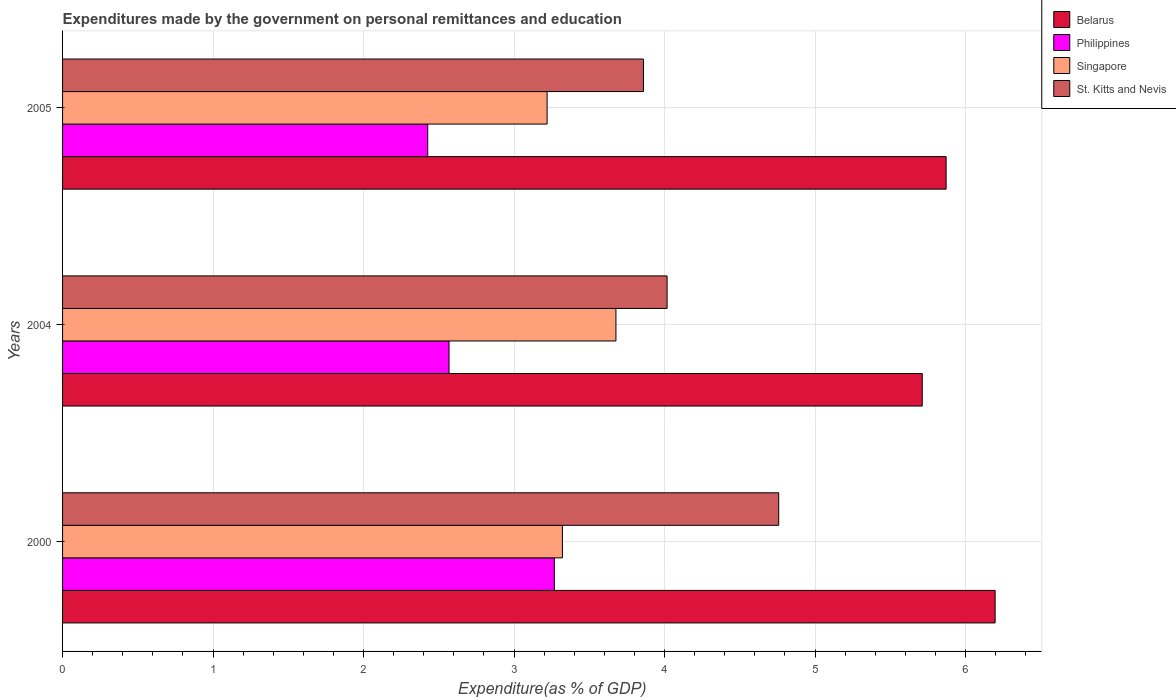How many different coloured bars are there?
Your answer should be compact. 4. Are the number of bars per tick equal to the number of legend labels?
Give a very brief answer. Yes. Are the number of bars on each tick of the Y-axis equal?
Provide a succinct answer. Yes. How many bars are there on the 1st tick from the top?
Ensure brevity in your answer.  4. How many bars are there on the 3rd tick from the bottom?
Make the answer very short. 4. What is the expenditures made by the government on personal remittances and education in St. Kitts and Nevis in 2004?
Provide a short and direct response. 4.02. Across all years, what is the maximum expenditures made by the government on personal remittances and education in Philippines?
Make the answer very short. 3.27. Across all years, what is the minimum expenditures made by the government on personal remittances and education in Philippines?
Your answer should be compact. 2.43. In which year was the expenditures made by the government on personal remittances and education in Belarus maximum?
Keep it short and to the point. 2000. In which year was the expenditures made by the government on personal remittances and education in St. Kitts and Nevis minimum?
Make the answer very short. 2005. What is the total expenditures made by the government on personal remittances and education in Belarus in the graph?
Offer a terse response. 17.78. What is the difference between the expenditures made by the government on personal remittances and education in Belarus in 2000 and that in 2005?
Offer a terse response. 0.33. What is the difference between the expenditures made by the government on personal remittances and education in Singapore in 2004 and the expenditures made by the government on personal remittances and education in St. Kitts and Nevis in 2000?
Offer a terse response. -1.08. What is the average expenditures made by the government on personal remittances and education in Singapore per year?
Offer a very short reply. 3.41. In the year 2000, what is the difference between the expenditures made by the government on personal remittances and education in Singapore and expenditures made by the government on personal remittances and education in St. Kitts and Nevis?
Ensure brevity in your answer.  -1.44. In how many years, is the expenditures made by the government on personal remittances and education in Singapore greater than 6 %?
Provide a short and direct response. 0. What is the ratio of the expenditures made by the government on personal remittances and education in Belarus in 2000 to that in 2005?
Your answer should be compact. 1.06. Is the expenditures made by the government on personal remittances and education in Belarus in 2000 less than that in 2005?
Your response must be concise. No. What is the difference between the highest and the second highest expenditures made by the government on personal remittances and education in Belarus?
Provide a succinct answer. 0.33. What is the difference between the highest and the lowest expenditures made by the government on personal remittances and education in Singapore?
Provide a short and direct response. 0.46. In how many years, is the expenditures made by the government on personal remittances and education in St. Kitts and Nevis greater than the average expenditures made by the government on personal remittances and education in St. Kitts and Nevis taken over all years?
Your response must be concise. 1. What does the 2nd bar from the top in 2000 represents?
Give a very brief answer. Singapore. What does the 3rd bar from the bottom in 2000 represents?
Provide a succinct answer. Singapore. Is it the case that in every year, the sum of the expenditures made by the government on personal remittances and education in Singapore and expenditures made by the government on personal remittances and education in Philippines is greater than the expenditures made by the government on personal remittances and education in Belarus?
Give a very brief answer. No. How many bars are there?
Your answer should be compact. 12. How many years are there in the graph?
Your answer should be compact. 3. Does the graph contain grids?
Provide a short and direct response. Yes. Where does the legend appear in the graph?
Keep it short and to the point. Top right. How are the legend labels stacked?
Your answer should be very brief. Vertical. What is the title of the graph?
Keep it short and to the point. Expenditures made by the government on personal remittances and education. What is the label or title of the X-axis?
Give a very brief answer. Expenditure(as % of GDP). What is the label or title of the Y-axis?
Provide a succinct answer. Years. What is the Expenditure(as % of GDP) in Belarus in 2000?
Keep it short and to the point. 6.2. What is the Expenditure(as % of GDP) in Philippines in 2000?
Provide a succinct answer. 3.27. What is the Expenditure(as % of GDP) in Singapore in 2000?
Give a very brief answer. 3.32. What is the Expenditure(as % of GDP) in St. Kitts and Nevis in 2000?
Ensure brevity in your answer.  4.76. What is the Expenditure(as % of GDP) in Belarus in 2004?
Offer a terse response. 5.71. What is the Expenditure(as % of GDP) in Philippines in 2004?
Give a very brief answer. 2.57. What is the Expenditure(as % of GDP) in Singapore in 2004?
Provide a succinct answer. 3.68. What is the Expenditure(as % of GDP) in St. Kitts and Nevis in 2004?
Give a very brief answer. 4.02. What is the Expenditure(as % of GDP) in Belarus in 2005?
Ensure brevity in your answer.  5.87. What is the Expenditure(as % of GDP) in Philippines in 2005?
Your response must be concise. 2.43. What is the Expenditure(as % of GDP) in Singapore in 2005?
Provide a succinct answer. 3.22. What is the Expenditure(as % of GDP) in St. Kitts and Nevis in 2005?
Make the answer very short. 3.86. Across all years, what is the maximum Expenditure(as % of GDP) of Belarus?
Keep it short and to the point. 6.2. Across all years, what is the maximum Expenditure(as % of GDP) of Philippines?
Offer a very short reply. 3.27. Across all years, what is the maximum Expenditure(as % of GDP) in Singapore?
Keep it short and to the point. 3.68. Across all years, what is the maximum Expenditure(as % of GDP) in St. Kitts and Nevis?
Offer a terse response. 4.76. Across all years, what is the minimum Expenditure(as % of GDP) in Belarus?
Provide a succinct answer. 5.71. Across all years, what is the minimum Expenditure(as % of GDP) in Philippines?
Ensure brevity in your answer.  2.43. Across all years, what is the minimum Expenditure(as % of GDP) of Singapore?
Your answer should be compact. 3.22. Across all years, what is the minimum Expenditure(as % of GDP) in St. Kitts and Nevis?
Make the answer very short. 3.86. What is the total Expenditure(as % of GDP) of Belarus in the graph?
Offer a terse response. 17.78. What is the total Expenditure(as % of GDP) in Philippines in the graph?
Your response must be concise. 8.26. What is the total Expenditure(as % of GDP) of Singapore in the graph?
Provide a succinct answer. 10.22. What is the total Expenditure(as % of GDP) of St. Kitts and Nevis in the graph?
Your response must be concise. 12.64. What is the difference between the Expenditure(as % of GDP) of Belarus in 2000 and that in 2004?
Keep it short and to the point. 0.48. What is the difference between the Expenditure(as % of GDP) in Philippines in 2000 and that in 2004?
Your response must be concise. 0.7. What is the difference between the Expenditure(as % of GDP) of Singapore in 2000 and that in 2004?
Your answer should be very brief. -0.36. What is the difference between the Expenditure(as % of GDP) in St. Kitts and Nevis in 2000 and that in 2004?
Provide a succinct answer. 0.74. What is the difference between the Expenditure(as % of GDP) in Belarus in 2000 and that in 2005?
Your answer should be very brief. 0.33. What is the difference between the Expenditure(as % of GDP) in Philippines in 2000 and that in 2005?
Offer a terse response. 0.84. What is the difference between the Expenditure(as % of GDP) in Singapore in 2000 and that in 2005?
Ensure brevity in your answer.  0.1. What is the difference between the Expenditure(as % of GDP) of St. Kitts and Nevis in 2000 and that in 2005?
Provide a short and direct response. 0.9. What is the difference between the Expenditure(as % of GDP) of Belarus in 2004 and that in 2005?
Give a very brief answer. -0.16. What is the difference between the Expenditure(as % of GDP) in Philippines in 2004 and that in 2005?
Make the answer very short. 0.14. What is the difference between the Expenditure(as % of GDP) in Singapore in 2004 and that in 2005?
Your answer should be compact. 0.46. What is the difference between the Expenditure(as % of GDP) in St. Kitts and Nevis in 2004 and that in 2005?
Your answer should be compact. 0.16. What is the difference between the Expenditure(as % of GDP) in Belarus in 2000 and the Expenditure(as % of GDP) in Philippines in 2004?
Your answer should be compact. 3.63. What is the difference between the Expenditure(as % of GDP) in Belarus in 2000 and the Expenditure(as % of GDP) in Singapore in 2004?
Offer a terse response. 2.52. What is the difference between the Expenditure(as % of GDP) of Belarus in 2000 and the Expenditure(as % of GDP) of St. Kitts and Nevis in 2004?
Your answer should be compact. 2.18. What is the difference between the Expenditure(as % of GDP) in Philippines in 2000 and the Expenditure(as % of GDP) in Singapore in 2004?
Keep it short and to the point. -0.41. What is the difference between the Expenditure(as % of GDP) of Philippines in 2000 and the Expenditure(as % of GDP) of St. Kitts and Nevis in 2004?
Make the answer very short. -0.75. What is the difference between the Expenditure(as % of GDP) in Singapore in 2000 and the Expenditure(as % of GDP) in St. Kitts and Nevis in 2004?
Ensure brevity in your answer.  -0.7. What is the difference between the Expenditure(as % of GDP) of Belarus in 2000 and the Expenditure(as % of GDP) of Philippines in 2005?
Provide a short and direct response. 3.77. What is the difference between the Expenditure(as % of GDP) in Belarus in 2000 and the Expenditure(as % of GDP) in Singapore in 2005?
Provide a short and direct response. 2.98. What is the difference between the Expenditure(as % of GDP) of Belarus in 2000 and the Expenditure(as % of GDP) of St. Kitts and Nevis in 2005?
Offer a terse response. 2.34. What is the difference between the Expenditure(as % of GDP) of Philippines in 2000 and the Expenditure(as % of GDP) of Singapore in 2005?
Keep it short and to the point. 0.05. What is the difference between the Expenditure(as % of GDP) in Philippines in 2000 and the Expenditure(as % of GDP) in St. Kitts and Nevis in 2005?
Your response must be concise. -0.59. What is the difference between the Expenditure(as % of GDP) in Singapore in 2000 and the Expenditure(as % of GDP) in St. Kitts and Nevis in 2005?
Provide a succinct answer. -0.54. What is the difference between the Expenditure(as % of GDP) of Belarus in 2004 and the Expenditure(as % of GDP) of Philippines in 2005?
Offer a very short reply. 3.29. What is the difference between the Expenditure(as % of GDP) of Belarus in 2004 and the Expenditure(as % of GDP) of Singapore in 2005?
Offer a very short reply. 2.49. What is the difference between the Expenditure(as % of GDP) in Belarus in 2004 and the Expenditure(as % of GDP) in St. Kitts and Nevis in 2005?
Your response must be concise. 1.85. What is the difference between the Expenditure(as % of GDP) of Philippines in 2004 and the Expenditure(as % of GDP) of Singapore in 2005?
Offer a very short reply. -0.65. What is the difference between the Expenditure(as % of GDP) in Philippines in 2004 and the Expenditure(as % of GDP) in St. Kitts and Nevis in 2005?
Give a very brief answer. -1.29. What is the difference between the Expenditure(as % of GDP) of Singapore in 2004 and the Expenditure(as % of GDP) of St. Kitts and Nevis in 2005?
Provide a succinct answer. -0.18. What is the average Expenditure(as % of GDP) of Belarus per year?
Ensure brevity in your answer.  5.93. What is the average Expenditure(as % of GDP) of Philippines per year?
Your answer should be compact. 2.75. What is the average Expenditure(as % of GDP) of Singapore per year?
Make the answer very short. 3.41. What is the average Expenditure(as % of GDP) of St. Kitts and Nevis per year?
Keep it short and to the point. 4.21. In the year 2000, what is the difference between the Expenditure(as % of GDP) in Belarus and Expenditure(as % of GDP) in Philippines?
Your answer should be compact. 2.93. In the year 2000, what is the difference between the Expenditure(as % of GDP) in Belarus and Expenditure(as % of GDP) in Singapore?
Provide a short and direct response. 2.88. In the year 2000, what is the difference between the Expenditure(as % of GDP) in Belarus and Expenditure(as % of GDP) in St. Kitts and Nevis?
Offer a terse response. 1.44. In the year 2000, what is the difference between the Expenditure(as % of GDP) in Philippines and Expenditure(as % of GDP) in Singapore?
Ensure brevity in your answer.  -0.05. In the year 2000, what is the difference between the Expenditure(as % of GDP) of Philippines and Expenditure(as % of GDP) of St. Kitts and Nevis?
Offer a terse response. -1.49. In the year 2000, what is the difference between the Expenditure(as % of GDP) in Singapore and Expenditure(as % of GDP) in St. Kitts and Nevis?
Offer a very short reply. -1.44. In the year 2004, what is the difference between the Expenditure(as % of GDP) in Belarus and Expenditure(as % of GDP) in Philippines?
Provide a short and direct response. 3.14. In the year 2004, what is the difference between the Expenditure(as % of GDP) in Belarus and Expenditure(as % of GDP) in Singapore?
Your answer should be very brief. 2.04. In the year 2004, what is the difference between the Expenditure(as % of GDP) of Belarus and Expenditure(as % of GDP) of St. Kitts and Nevis?
Your answer should be compact. 1.7. In the year 2004, what is the difference between the Expenditure(as % of GDP) of Philippines and Expenditure(as % of GDP) of Singapore?
Offer a terse response. -1.11. In the year 2004, what is the difference between the Expenditure(as % of GDP) in Philippines and Expenditure(as % of GDP) in St. Kitts and Nevis?
Keep it short and to the point. -1.45. In the year 2004, what is the difference between the Expenditure(as % of GDP) in Singapore and Expenditure(as % of GDP) in St. Kitts and Nevis?
Ensure brevity in your answer.  -0.34. In the year 2005, what is the difference between the Expenditure(as % of GDP) in Belarus and Expenditure(as % of GDP) in Philippines?
Offer a terse response. 3.44. In the year 2005, what is the difference between the Expenditure(as % of GDP) in Belarus and Expenditure(as % of GDP) in Singapore?
Give a very brief answer. 2.65. In the year 2005, what is the difference between the Expenditure(as % of GDP) in Belarus and Expenditure(as % of GDP) in St. Kitts and Nevis?
Your answer should be very brief. 2.01. In the year 2005, what is the difference between the Expenditure(as % of GDP) in Philippines and Expenditure(as % of GDP) in Singapore?
Offer a terse response. -0.79. In the year 2005, what is the difference between the Expenditure(as % of GDP) in Philippines and Expenditure(as % of GDP) in St. Kitts and Nevis?
Your answer should be compact. -1.43. In the year 2005, what is the difference between the Expenditure(as % of GDP) in Singapore and Expenditure(as % of GDP) in St. Kitts and Nevis?
Provide a succinct answer. -0.64. What is the ratio of the Expenditure(as % of GDP) of Belarus in 2000 to that in 2004?
Your answer should be compact. 1.08. What is the ratio of the Expenditure(as % of GDP) of Philippines in 2000 to that in 2004?
Your answer should be compact. 1.27. What is the ratio of the Expenditure(as % of GDP) of Singapore in 2000 to that in 2004?
Your response must be concise. 0.9. What is the ratio of the Expenditure(as % of GDP) in St. Kitts and Nevis in 2000 to that in 2004?
Offer a terse response. 1.18. What is the ratio of the Expenditure(as % of GDP) of Belarus in 2000 to that in 2005?
Your response must be concise. 1.06. What is the ratio of the Expenditure(as % of GDP) of Philippines in 2000 to that in 2005?
Offer a terse response. 1.35. What is the ratio of the Expenditure(as % of GDP) in Singapore in 2000 to that in 2005?
Give a very brief answer. 1.03. What is the ratio of the Expenditure(as % of GDP) in St. Kitts and Nevis in 2000 to that in 2005?
Make the answer very short. 1.23. What is the ratio of the Expenditure(as % of GDP) of Philippines in 2004 to that in 2005?
Ensure brevity in your answer.  1.06. What is the ratio of the Expenditure(as % of GDP) in Singapore in 2004 to that in 2005?
Give a very brief answer. 1.14. What is the ratio of the Expenditure(as % of GDP) of St. Kitts and Nevis in 2004 to that in 2005?
Give a very brief answer. 1.04. What is the difference between the highest and the second highest Expenditure(as % of GDP) of Belarus?
Offer a terse response. 0.33. What is the difference between the highest and the second highest Expenditure(as % of GDP) in Philippines?
Keep it short and to the point. 0.7. What is the difference between the highest and the second highest Expenditure(as % of GDP) in Singapore?
Offer a very short reply. 0.36. What is the difference between the highest and the second highest Expenditure(as % of GDP) in St. Kitts and Nevis?
Keep it short and to the point. 0.74. What is the difference between the highest and the lowest Expenditure(as % of GDP) in Belarus?
Provide a succinct answer. 0.48. What is the difference between the highest and the lowest Expenditure(as % of GDP) of Philippines?
Keep it short and to the point. 0.84. What is the difference between the highest and the lowest Expenditure(as % of GDP) of Singapore?
Your response must be concise. 0.46. What is the difference between the highest and the lowest Expenditure(as % of GDP) in St. Kitts and Nevis?
Provide a succinct answer. 0.9. 